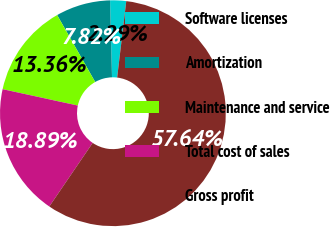Convert chart to OTSL. <chart><loc_0><loc_0><loc_500><loc_500><pie_chart><fcel>Software licenses<fcel>Amortization<fcel>Maintenance and service<fcel>Total cost of sales<fcel>Gross profit<nl><fcel>2.29%<fcel>7.82%<fcel>13.36%<fcel>18.89%<fcel>57.64%<nl></chart> 